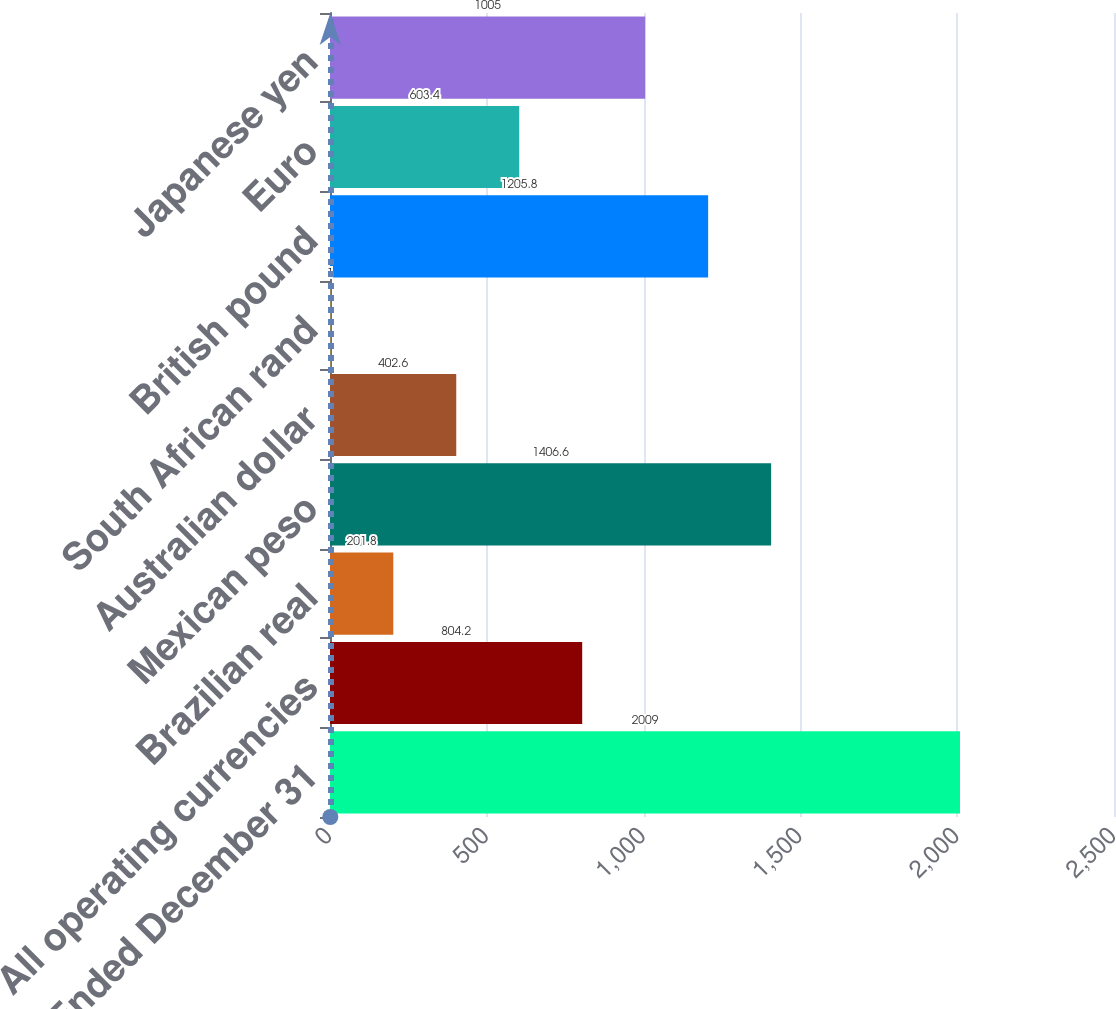Convert chart. <chart><loc_0><loc_0><loc_500><loc_500><bar_chart><fcel>Year Ended December 31<fcel>All operating currencies<fcel>Brazilian real<fcel>Mexican peso<fcel>Australian dollar<fcel>South African rand<fcel>British pound<fcel>Euro<fcel>Japanese yen<nl><fcel>2009<fcel>804.2<fcel>201.8<fcel>1406.6<fcel>402.6<fcel>1<fcel>1205.8<fcel>603.4<fcel>1005<nl></chart> 